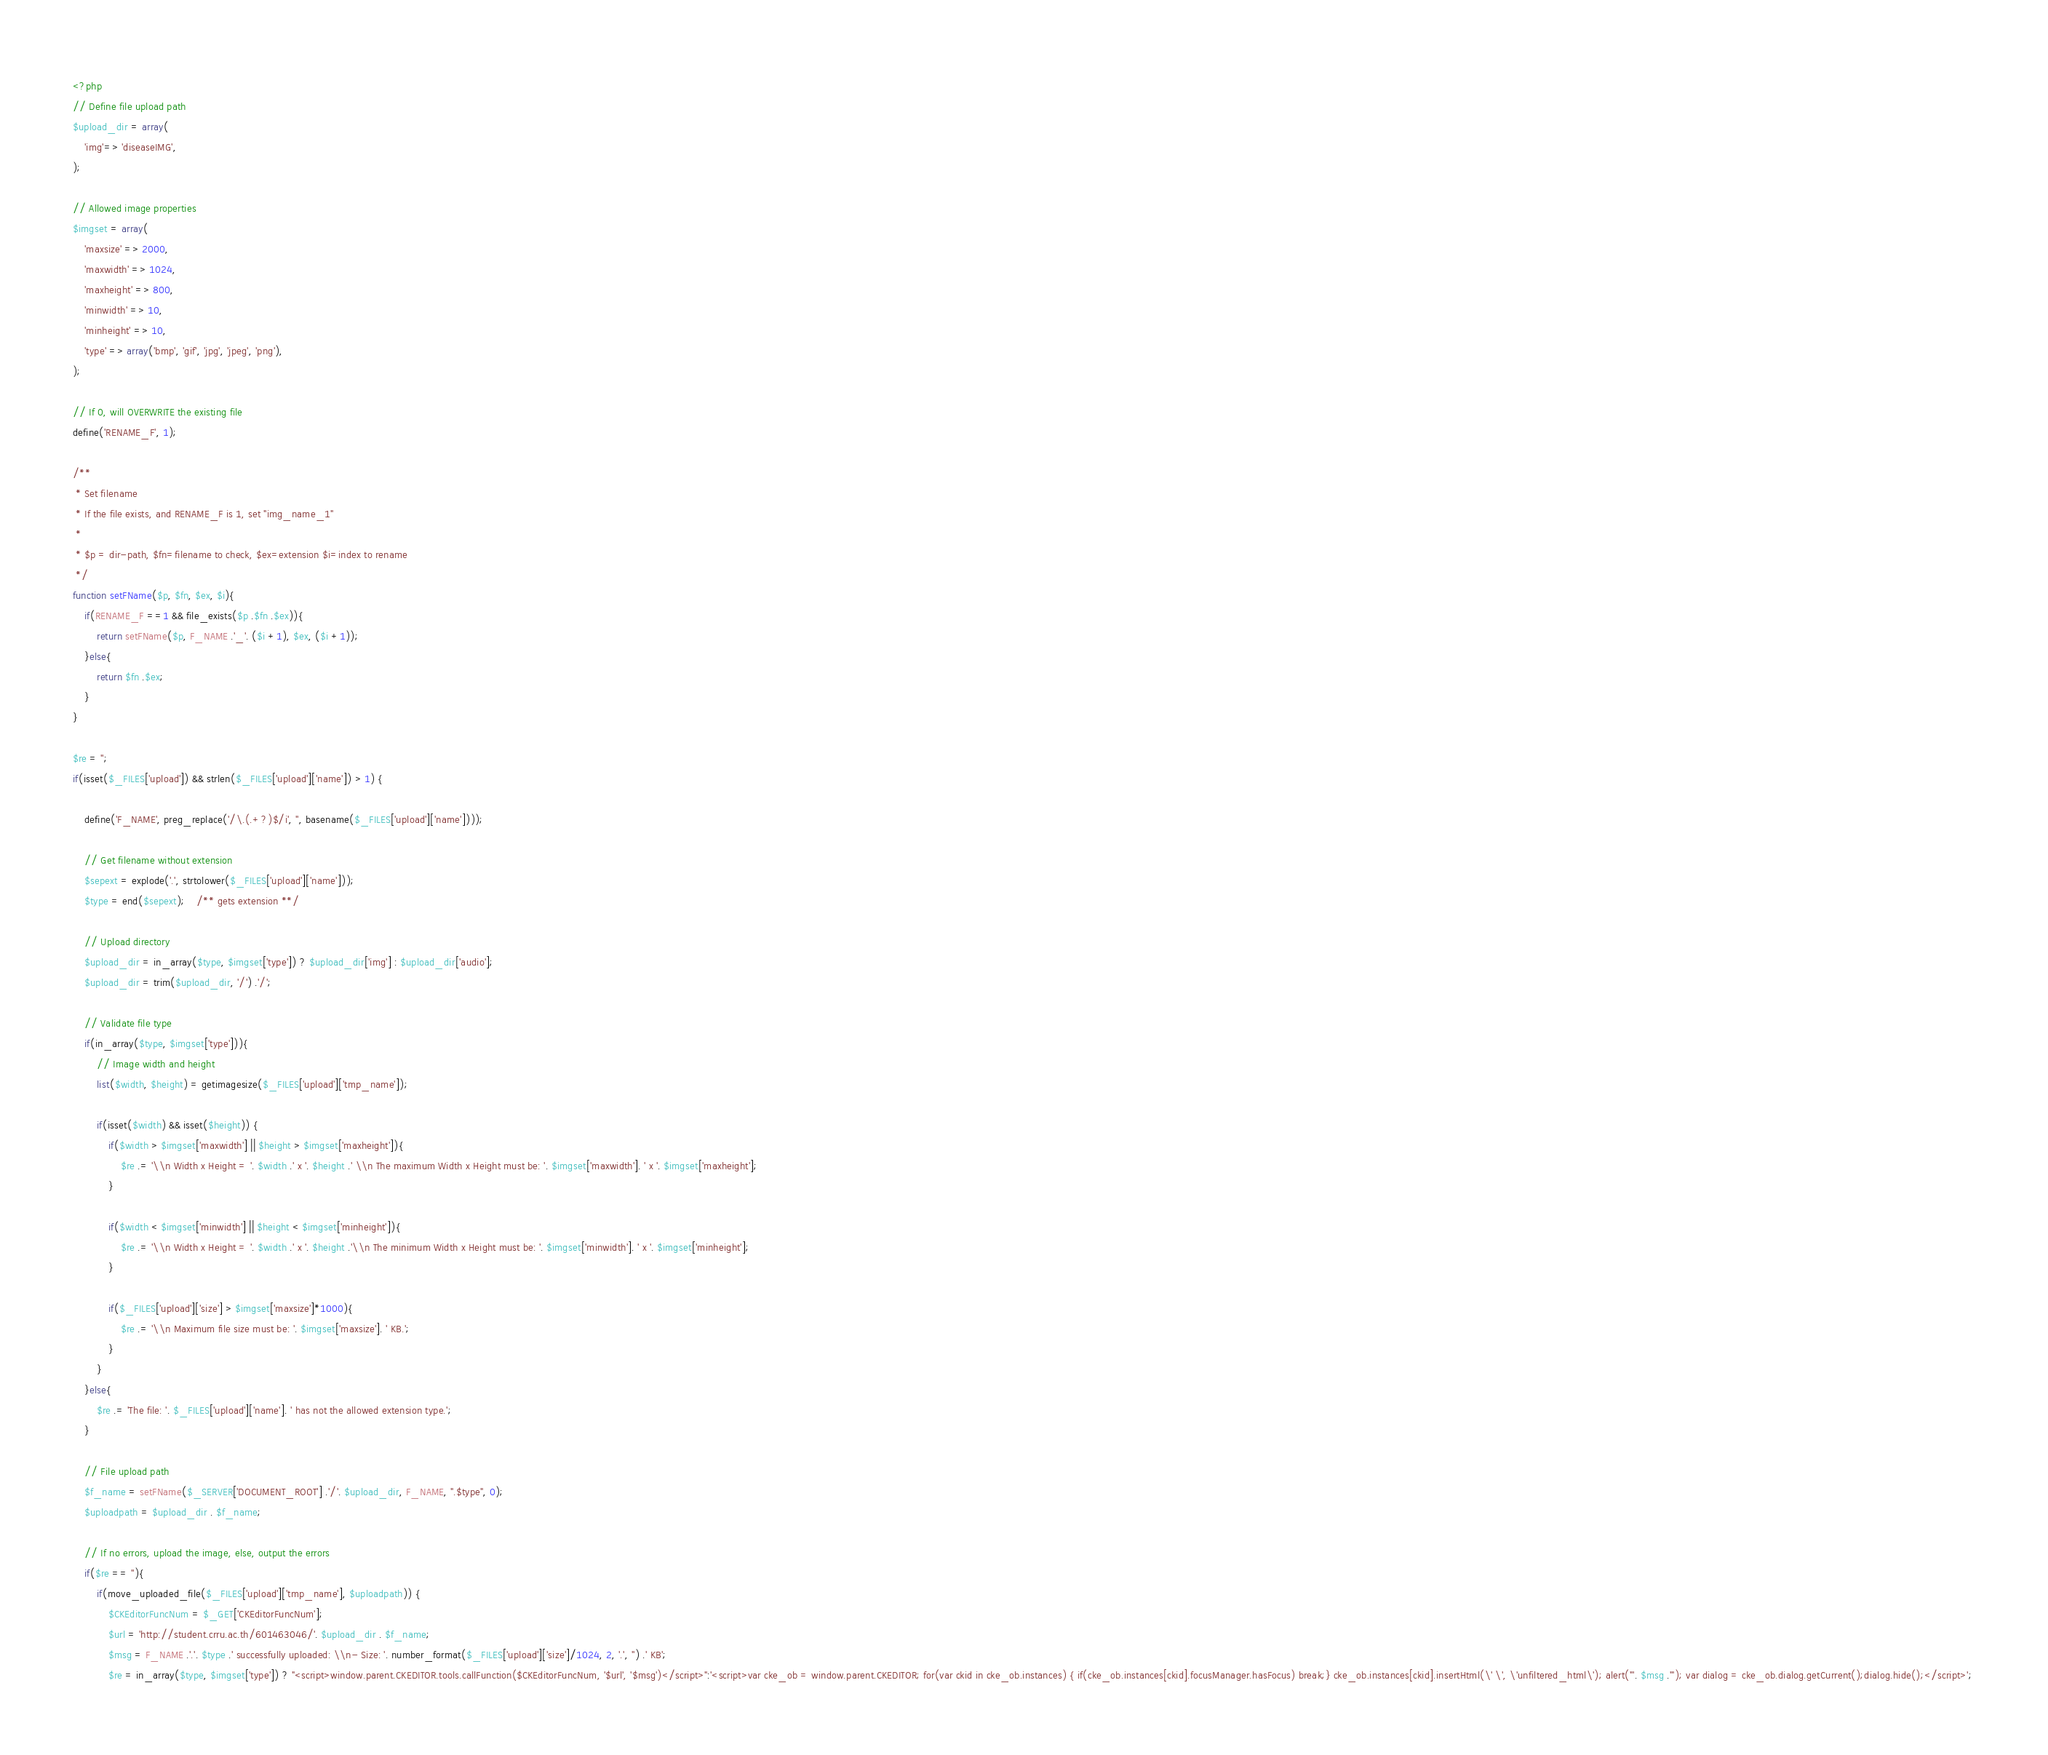Convert code to text. <code><loc_0><loc_0><loc_500><loc_500><_PHP_><?php 
// Define file upload path 
$upload_dir = array( 
    'img'=> 'diseaseIMG', 
); 
 
// Allowed image properties  
$imgset = array( 
    'maxsize' => 2000, 
    'maxwidth' => 1024, 
    'maxheight' => 800, 
    'minwidth' => 10, 
    'minheight' => 10, 
    'type' => array('bmp', 'gif', 'jpg', 'jpeg', 'png'), 
); 
 
// If 0, will OVERWRITE the existing file 
define('RENAME_F', 1); 
 
/** 
 * Set filename 
 * If the file exists, and RENAME_F is 1, set "img_name_1" 
 * 
 * $p = dir-path, $fn=filename to check, $ex=extension $i=index to rename 
 */ 
function setFName($p, $fn, $ex, $i){ 
    if(RENAME_F ==1 && file_exists($p .$fn .$ex)){ 
        return setFName($p, F_NAME .'_'. ($i +1), $ex, ($i +1)); 
    }else{ 
        return $fn .$ex; 
    } 
} 
 
$re = ''; 
if(isset($_FILES['upload']) && strlen($_FILES['upload']['name']) > 1) { 
 
    define('F_NAME', preg_replace('/\.(.+?)$/i', '', basename($_FILES['upload']['name'])));   
 
    // Get filename without extension 
    $sepext = explode('.', strtolower($_FILES['upload']['name'])); 
    $type = end($sepext);    /** gets extension **/ 
     
    // Upload directory 
    $upload_dir = in_array($type, $imgset['type']) ? $upload_dir['img'] : $upload_dir['audio']; 
    $upload_dir = trim($upload_dir, '/') .'/'; 
 
    // Validate file type 
    if(in_array($type, $imgset['type'])){ 
        // Image width and height 
        list($width, $height) = getimagesize($_FILES['upload']['tmp_name']); 
 
        if(isset($width) && isset($height)) { 
            if($width > $imgset['maxwidth'] || $height > $imgset['maxheight']){ 
                $re .= '\\n Width x Height = '. $width .' x '. $height .' \\n The maximum Width x Height must be: '. $imgset['maxwidth']. ' x '. $imgset['maxheight']; 
            } 
 
            if($width < $imgset['minwidth'] || $height < $imgset['minheight']){ 
                $re .= '\\n Width x Height = '. $width .' x '. $height .'\\n The minimum Width x Height must be: '. $imgset['minwidth']. ' x '. $imgset['minheight']; 
            } 
 
            if($_FILES['upload']['size'] > $imgset['maxsize']*1000){ 
                $re .= '\\n Maximum file size must be: '. $imgset['maxsize']. ' KB.'; 
            } 
        } 
    }else{ 
        $re .= 'The file: '. $_FILES['upload']['name']. ' has not the allowed extension type.'; 
    } 
     
    // File upload path 
    $f_name = setFName($_SERVER['DOCUMENT_ROOT'] .'/'. $upload_dir, F_NAME, ".$type", 0); 
    $uploadpath = $upload_dir . $f_name; 
 
    // If no errors, upload the image, else, output the errors 
    if($re == ''){ 
        if(move_uploaded_file($_FILES['upload']['tmp_name'], $uploadpath)) { 
            $CKEditorFuncNum = $_GET['CKEditorFuncNum']; 
            $url = 'http://student.crru.ac.th/601463046/'. $upload_dir . $f_name; 
            $msg = F_NAME .'.'. $type .' successfully uploaded: \\n- Size: '. number_format($_FILES['upload']['size']/1024, 2, '.', '') .' KB'; 
            $re = in_array($type, $imgset['type']) ? "<script>window.parent.CKEDITOR.tools.callFunction($CKEditorFuncNum, '$url', '$msg')</script>":'<script>var cke_ob = window.parent.CKEDITOR; for(var ckid in cke_ob.instances) { if(cke_ob.instances[ckid].focusManager.hasFocus) break;} cke_ob.instances[ckid].insertHtml(\' \', \'unfiltered_html\'); alert("'. $msg .'"); var dialog = cke_ob.dialog.getCurrent();dialog.hide();</script>'; </code> 